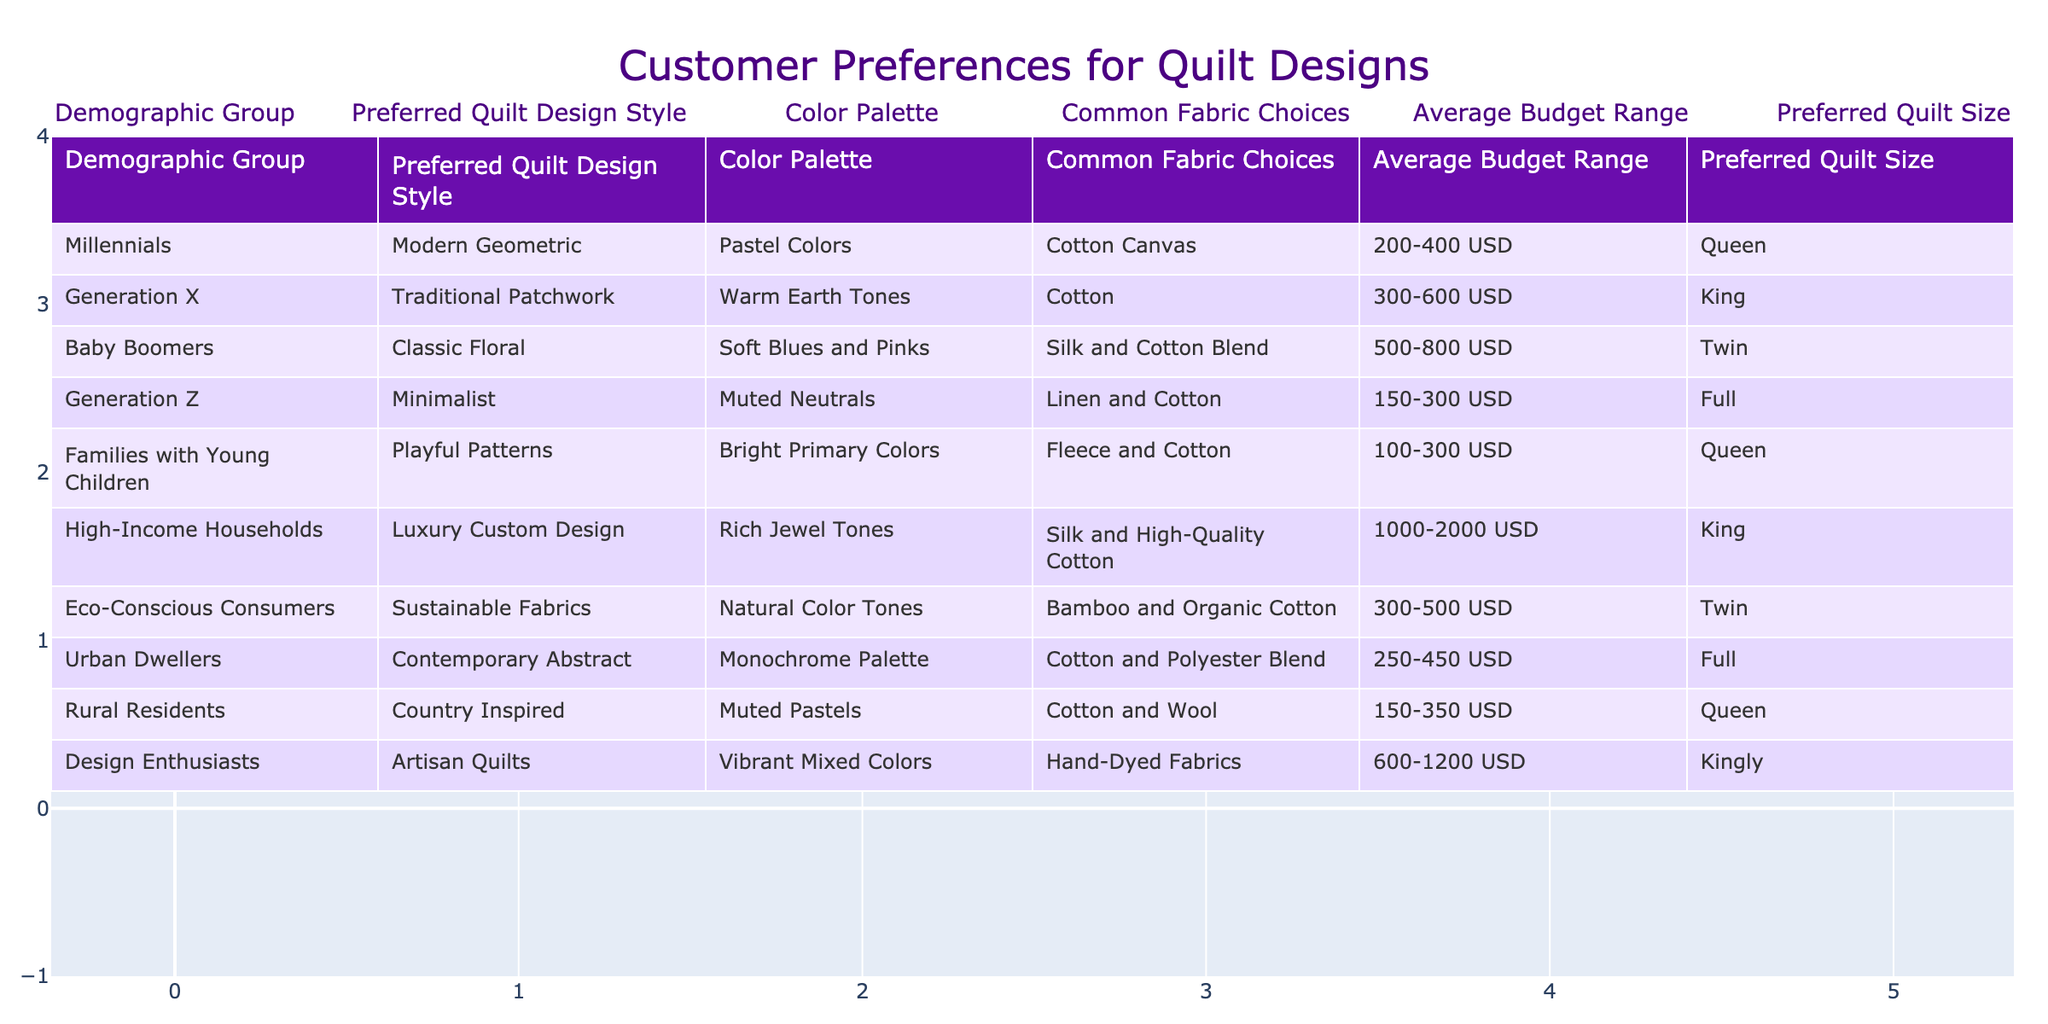What quilt design style is preferred by Generation Z? The table indicates that Generation Z prefers the "Minimalist" quilt design style.
Answer: Minimalist Which demographic group has the highest average budget range for quilts? The High-Income Households group has the highest average budget range of 1000-2000 USD compared to other groups in the table.
Answer: High-Income Households What are the common fabric choices for Baby Boomers? The common fabric choices for Baby Boomers are "Silk and Cotton Blend," as listed in the table.
Answer: Silk and Cotton Blend Is the preferred quilt size for Families with Young Children larger than that for Eco-Conscious Consumers? Families with Young Children prefer a quilt size of "Queen," while Eco-Conscious Consumers prefer "Twin." Since Queen is larger than Twin, the answer is yes.
Answer: Yes Which quilt design style is associated with high budgets and which demographic prefers it? The "Luxury Custom Design" quilt design style is associated with high budgets, and the demographic group that prefers it is "High-Income Households."
Answer: Luxury Custom Design, High-Income Households Calculate the average budget range for all demographic groups that prefer quilts with pastel colors. The demographic groups preferring pastel colors are Millennials, Rural Residents, and Families with Young Children, with budget ranges of 200-400, 150-350, and 100-300 USD, respectively. The average is calculated as: (300 + 250 + 200)/3 = 250 USD, considering the midpoint of each range.
Answer: 250 USD Which demographic has the most vibrant color palette according to the table? The "Design Enthusiasts" demographic has the most vibrant color palette as they prefer "Vibrant Mixed Colors."
Answer: Design Enthusiasts Are there any demographics that prefer a quilt size of Full? Yes, both Generation Z and Urban Dwellers prefer a quilt size of Full, as seen in the table.
Answer: Yes What is the color palette preferred by Millennials? Millennials prefer a color palette of "Pastel Colors" according to the table.
Answer: Pastel Colors Compare the common fabric choices between Generation X and Families with Young Children. Generation X prefers "Cotton," while Families with Young Children use "Fleece and Cotton," indicating that Generation X opts for a more traditional fabric compared to the playful choice for families.
Answer: Cotton vs. Fleece and Cotton 